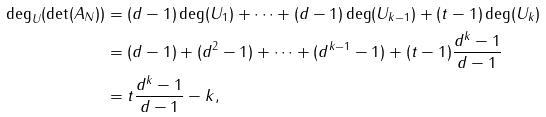Convert formula to latex. <formula><loc_0><loc_0><loc_500><loc_500>\deg _ { U } ( \det ( A _ { N } ) ) & = ( d - 1 ) \deg ( U _ { 1 } ) + \dots + ( d - 1 ) \deg ( U _ { k - 1 } ) + ( t - 1 ) \deg ( U _ { k } ) \\ & = ( d - 1 ) + ( d ^ { 2 } - 1 ) + \dots + ( d ^ { k - 1 } - 1 ) + ( t - 1 ) \frac { d ^ { k } - 1 } { d - 1 } \\ & = t \frac { d ^ { k } - 1 } { d - 1 } - k ,</formula> 